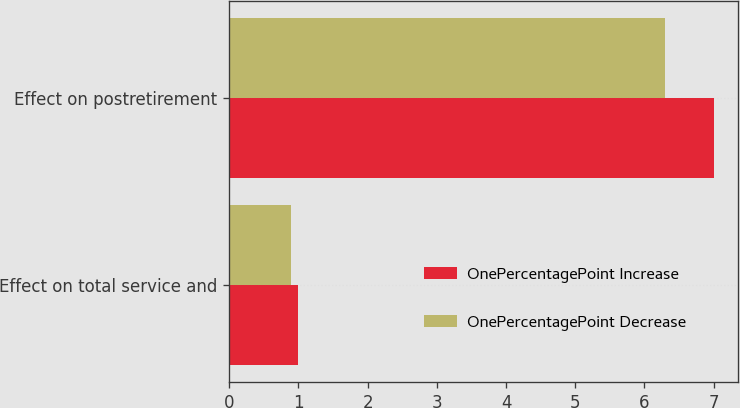Convert chart. <chart><loc_0><loc_0><loc_500><loc_500><stacked_bar_chart><ecel><fcel>Effect on total service and<fcel>Effect on postretirement<nl><fcel>OnePercentagePoint Increase<fcel>1<fcel>7<nl><fcel>OnePercentagePoint Decrease<fcel>0.9<fcel>6.3<nl></chart> 